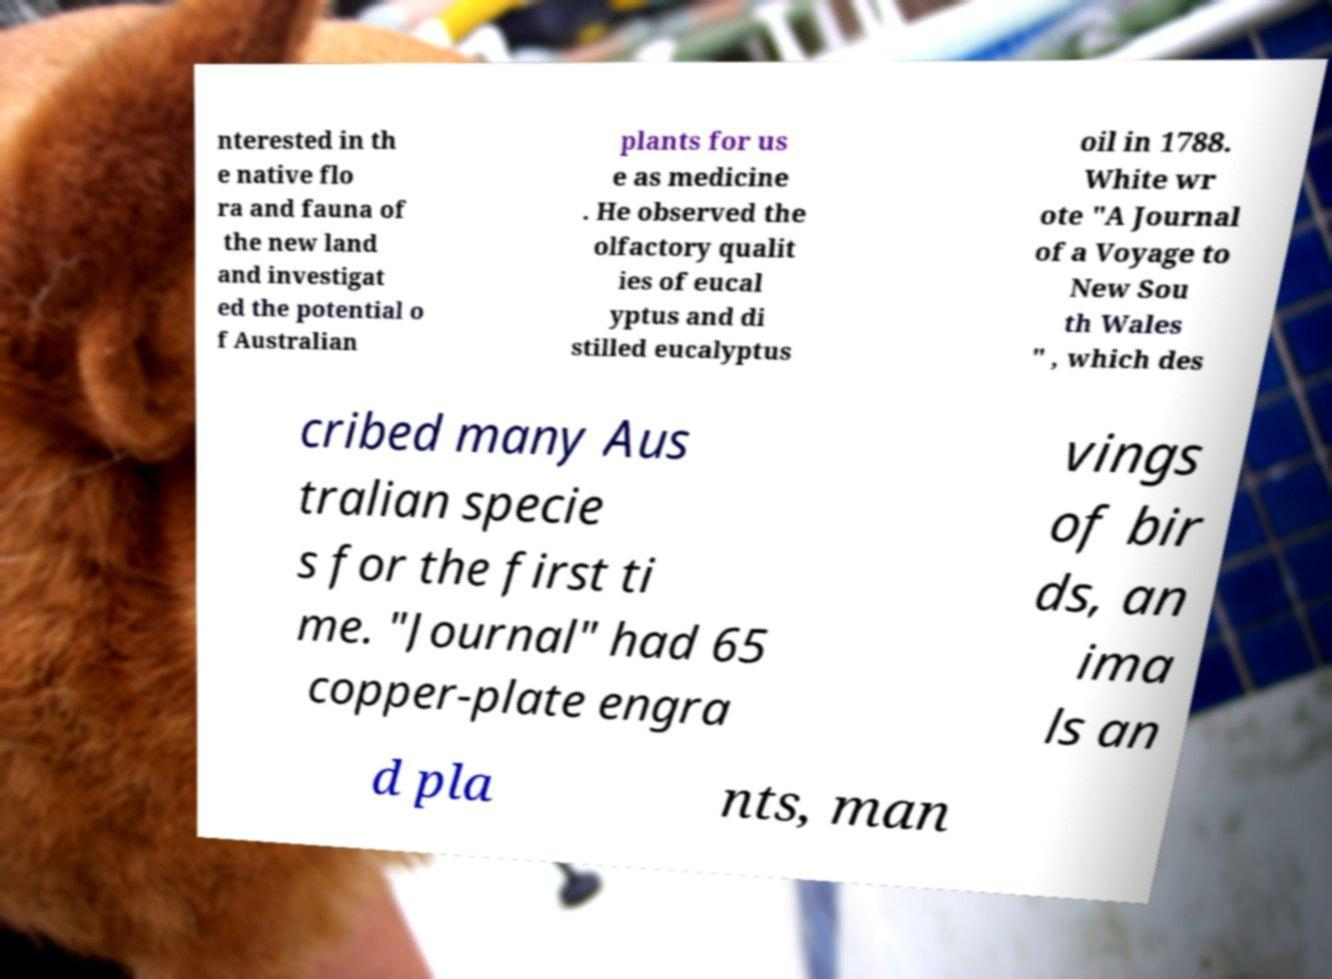For documentation purposes, I need the text within this image transcribed. Could you provide that? nterested in th e native flo ra and fauna of the new land and investigat ed the potential o f Australian plants for us e as medicine . He observed the olfactory qualit ies of eucal yptus and di stilled eucalyptus oil in 1788. White wr ote "A Journal of a Voyage to New Sou th Wales " , which des cribed many Aus tralian specie s for the first ti me. "Journal" had 65 copper-plate engra vings of bir ds, an ima ls an d pla nts, man 